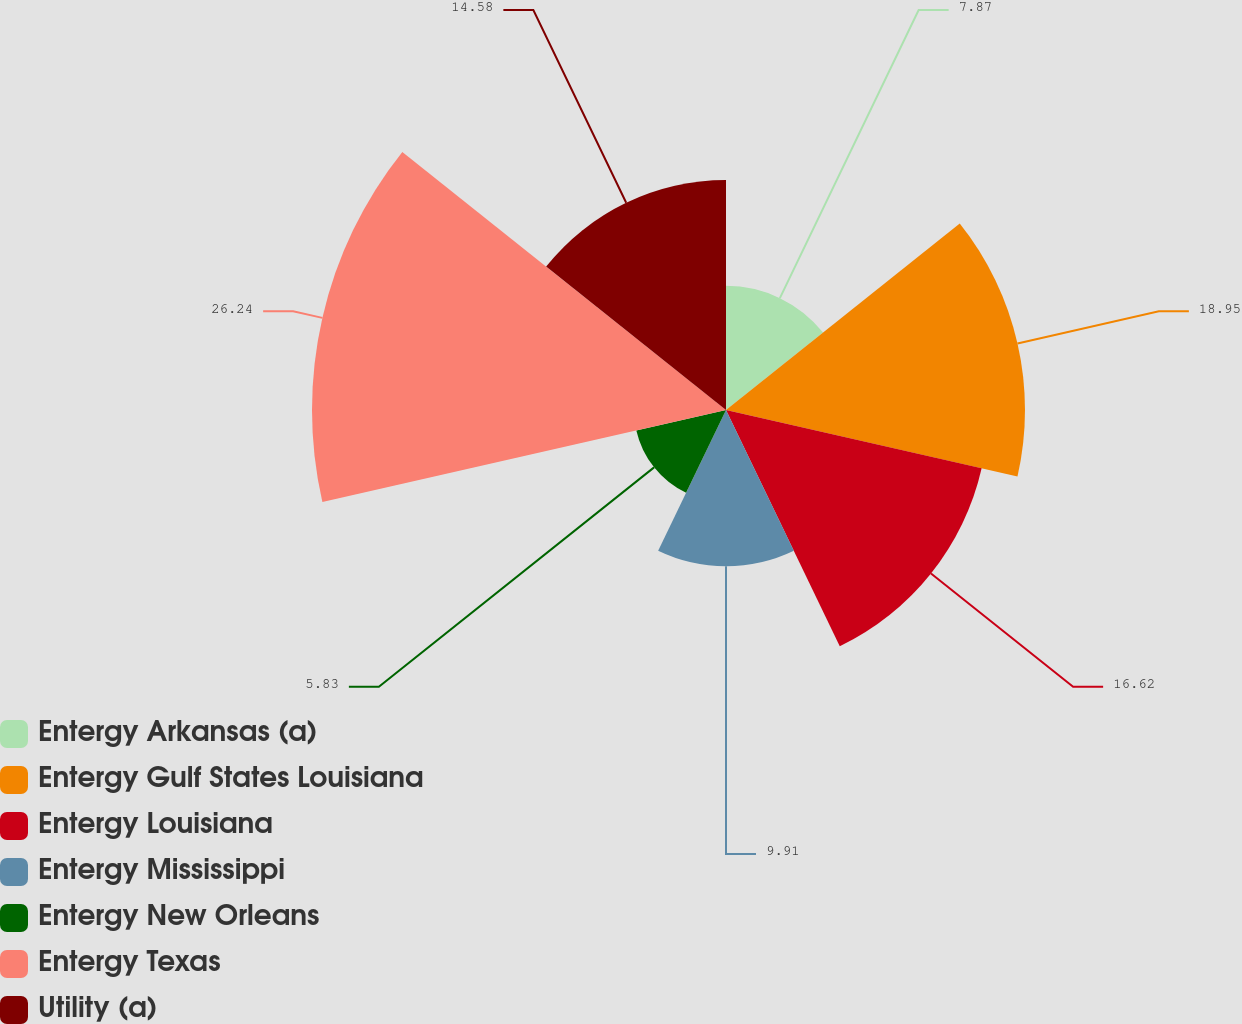Convert chart to OTSL. <chart><loc_0><loc_0><loc_500><loc_500><pie_chart><fcel>Entergy Arkansas (a)<fcel>Entergy Gulf States Louisiana<fcel>Entergy Louisiana<fcel>Entergy Mississippi<fcel>Entergy New Orleans<fcel>Entergy Texas<fcel>Utility (a)<nl><fcel>7.87%<fcel>18.95%<fcel>16.62%<fcel>9.91%<fcel>5.83%<fcel>26.24%<fcel>14.58%<nl></chart> 